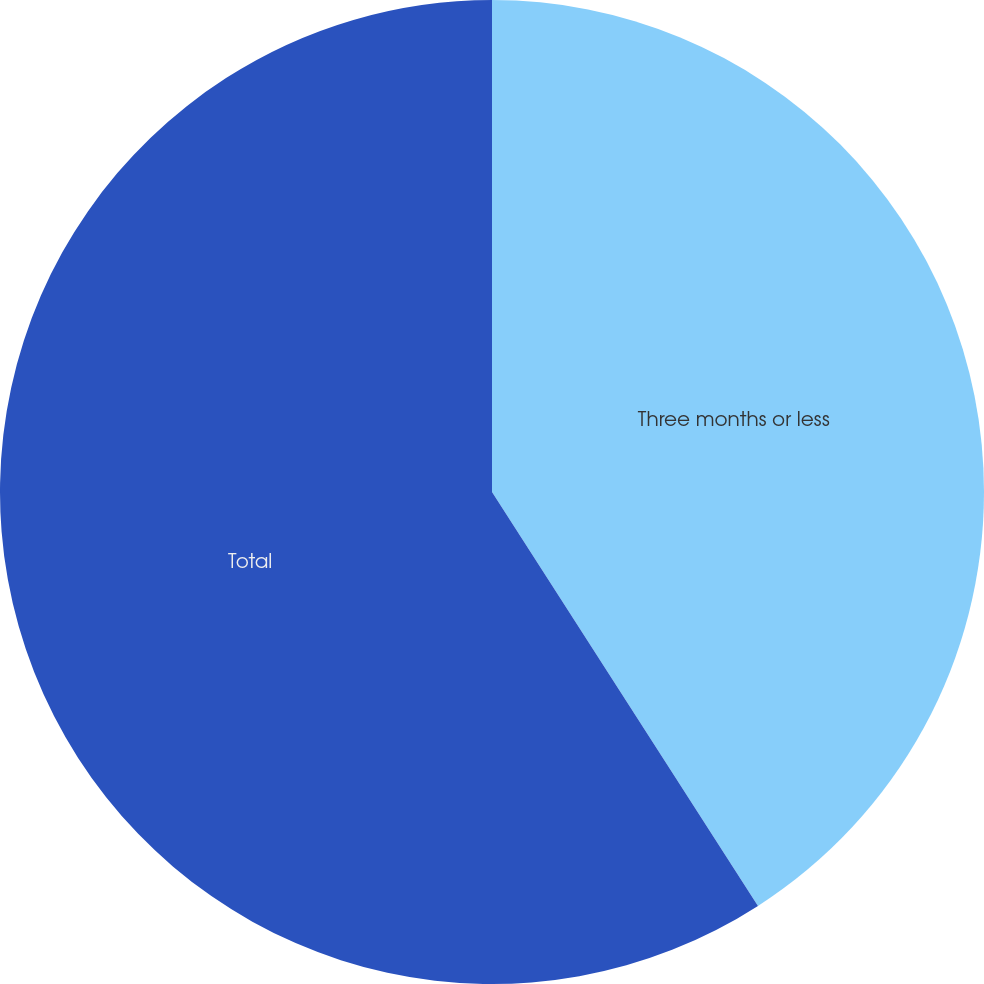Convert chart to OTSL. <chart><loc_0><loc_0><loc_500><loc_500><pie_chart><fcel>Three months or less<fcel>Total<nl><fcel>40.91%<fcel>59.09%<nl></chart> 